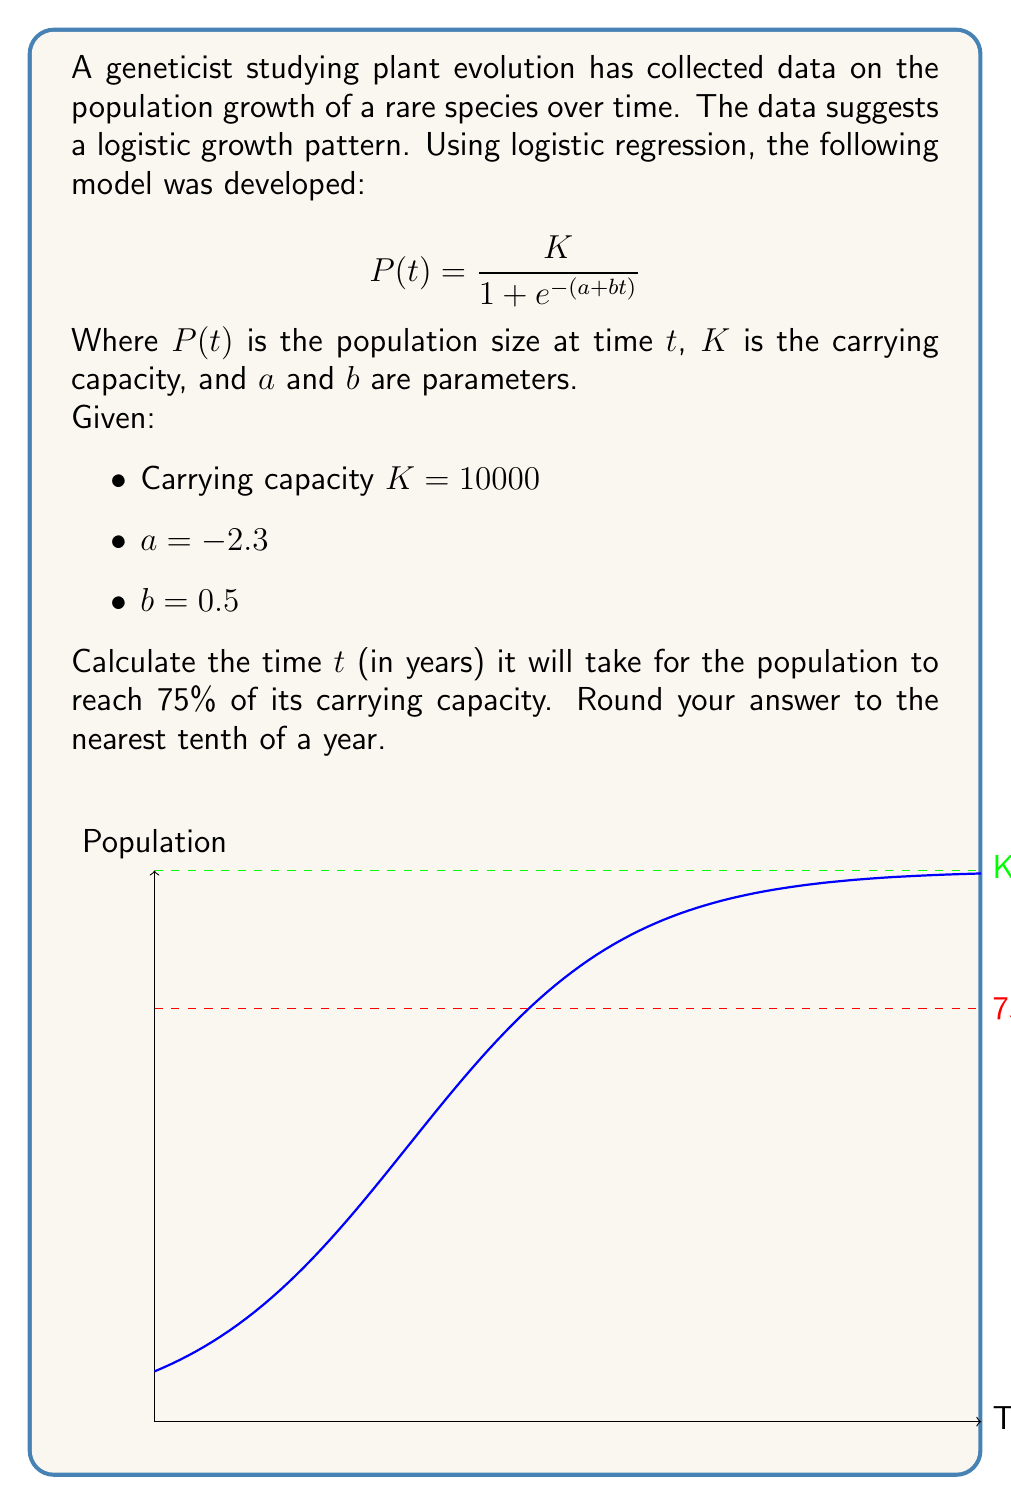Provide a solution to this math problem. Let's approach this step-by-step:

1) We want to find $t$ when the population $P(t)$ is 75% of the carrying capacity $K$. This means:

   $P(t) = 0.75K = 0.75 \times 10000 = 7500$

2) We can set up the equation:

   $$7500 = \frac{10000}{1 + e^{-(a + bt)}}$$

3) Let's solve this equation for $t$:

   $$7500(1 + e^{-(a + bt)}) = 10000$$
   $$7500 + 7500e^{-(a + bt)} = 10000$$
   $$7500e^{-(a + bt)} = 2500$$
   $$e^{-(a + bt)} = \frac{1}{3}$$

4) Taking the natural log of both sides:

   $$-(a + bt) = \ln(\frac{1}{3})$$
   $$a + bt = -\ln(\frac{1}{3})$$

5) Substituting the known values:

   $$-2.3 + 0.5t = -\ln(\frac{1}{3})$$

6) Solving for $t$:

   $$0.5t = -\ln(\frac{1}{3}) + 2.3$$
   $$0.5t = \ln(3) + 2.3$$
   $$t = \frac{\ln(3) + 2.3}{0.5}$$

7) Calculate the result:

   $$t \approx 7.82 \text{ years}$$

8) Rounding to the nearest tenth:

   $$t \approx 7.8 \text{ years}$$
Answer: 7.8 years 